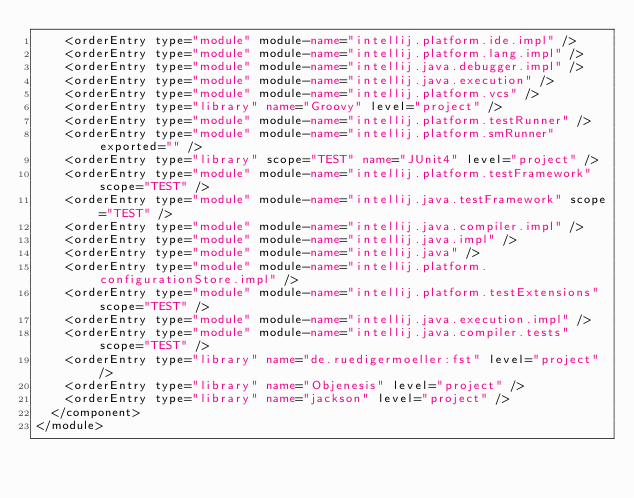Convert code to text. <code><loc_0><loc_0><loc_500><loc_500><_XML_>    <orderEntry type="module" module-name="intellij.platform.ide.impl" />
    <orderEntry type="module" module-name="intellij.platform.lang.impl" />
    <orderEntry type="module" module-name="intellij.java.debugger.impl" />
    <orderEntry type="module" module-name="intellij.java.execution" />
    <orderEntry type="module" module-name="intellij.platform.vcs" />
    <orderEntry type="library" name="Groovy" level="project" />
    <orderEntry type="module" module-name="intellij.platform.testRunner" />
    <orderEntry type="module" module-name="intellij.platform.smRunner" exported="" />
    <orderEntry type="library" scope="TEST" name="JUnit4" level="project" />
    <orderEntry type="module" module-name="intellij.platform.testFramework" scope="TEST" />
    <orderEntry type="module" module-name="intellij.java.testFramework" scope="TEST" />
    <orderEntry type="module" module-name="intellij.java.compiler.impl" />
    <orderEntry type="module" module-name="intellij.java.impl" />
    <orderEntry type="module" module-name="intellij.java" />
    <orderEntry type="module" module-name="intellij.platform.configurationStore.impl" />
    <orderEntry type="module" module-name="intellij.platform.testExtensions" scope="TEST" />
    <orderEntry type="module" module-name="intellij.java.execution.impl" />
    <orderEntry type="module" module-name="intellij.java.compiler.tests" scope="TEST" />
    <orderEntry type="library" name="de.ruedigermoeller:fst" level="project" />
    <orderEntry type="library" name="Objenesis" level="project" />
    <orderEntry type="library" name="jackson" level="project" />
  </component>
</module></code> 